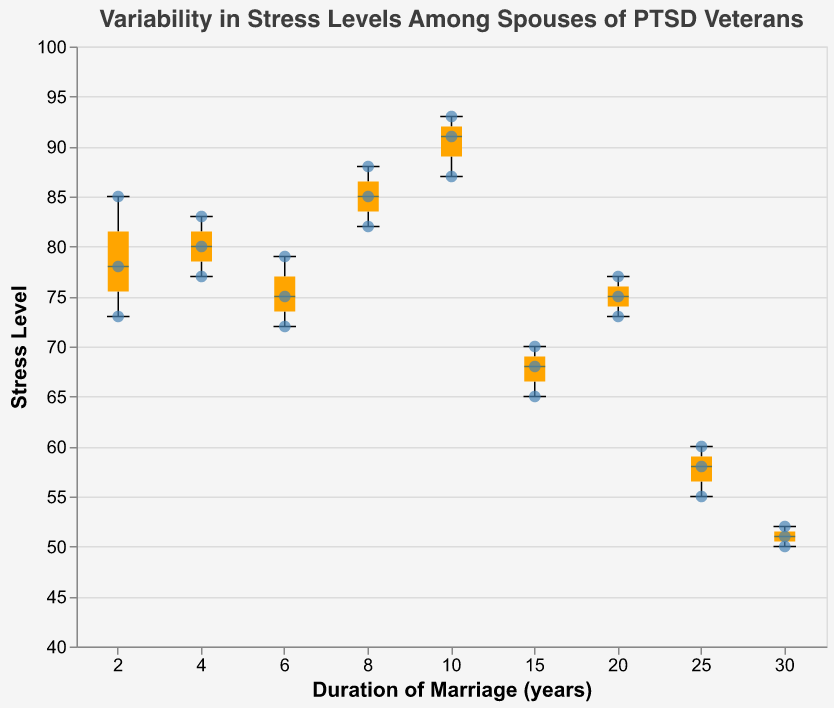What is the title of the figure? The figure title is usually at the top and is labeled clearly.
Answer: Variability in Stress Levels Among Spouses of PTSD Veterans What is the range of Stress Levels for spouses married for 10 years? The box plot for 10 years shows the minimum and maximum stress levels, which are indicated by the ends of the whiskers in the box plot.
Answer: 87 to 93 Which group has the lowest median stress level? The median value is indicated by a horizontal line inside the box for each duration of marriage. The lowest median is for the group with the longest duration whose median line is closest to the bottom.
Answer: 30 years How does the median stress level for spouses married for 4 years compare to those married for 8 years? Compare the median lines in the box plots for 4 years and 8 years. The median line for 4 years is lower than that for 8 years.
Answer: Lower For spouses married for 6 years, what are the stress levels of all individuals? The scatter points superimposed on the box plot show the individual stress levels. For 6 years, identify the y-values of these points.
Answer: 72, 75, 79 What can be said about the spread of stress levels for spouses married for 15 years compared to those married for 20 years? Look at the length of the boxes and the whiskers. A longer box and whiskers indicate more variability in data. Compare these lengths between 15 and 20 years.
Answer: 15 years has more spread What is the most common duration of marriage in the data? The duration with the most scatter points plotted on the figure is the most common. Count the number of points at each duration and find the duration with the highest count.
Answer: 10 years (3 points) What is the difference between the highest and lowest stress levels for spouses married for 25 years? Subtract the lowest stress level from the highest stress level in the whiskers of the box plot for 25 years.
Answer: 60 - 55 = 5 Which group has the largest range of stress levels? Look for the box plot with the longest whiskers, as this represents the group with the largest range.
Answer: 10 years Which duration of marriage appears to have the most consistent stress levels? Consistency indicates less variability, so find the box plot with the shortest whiskers and box length.
Answer: 30 years 